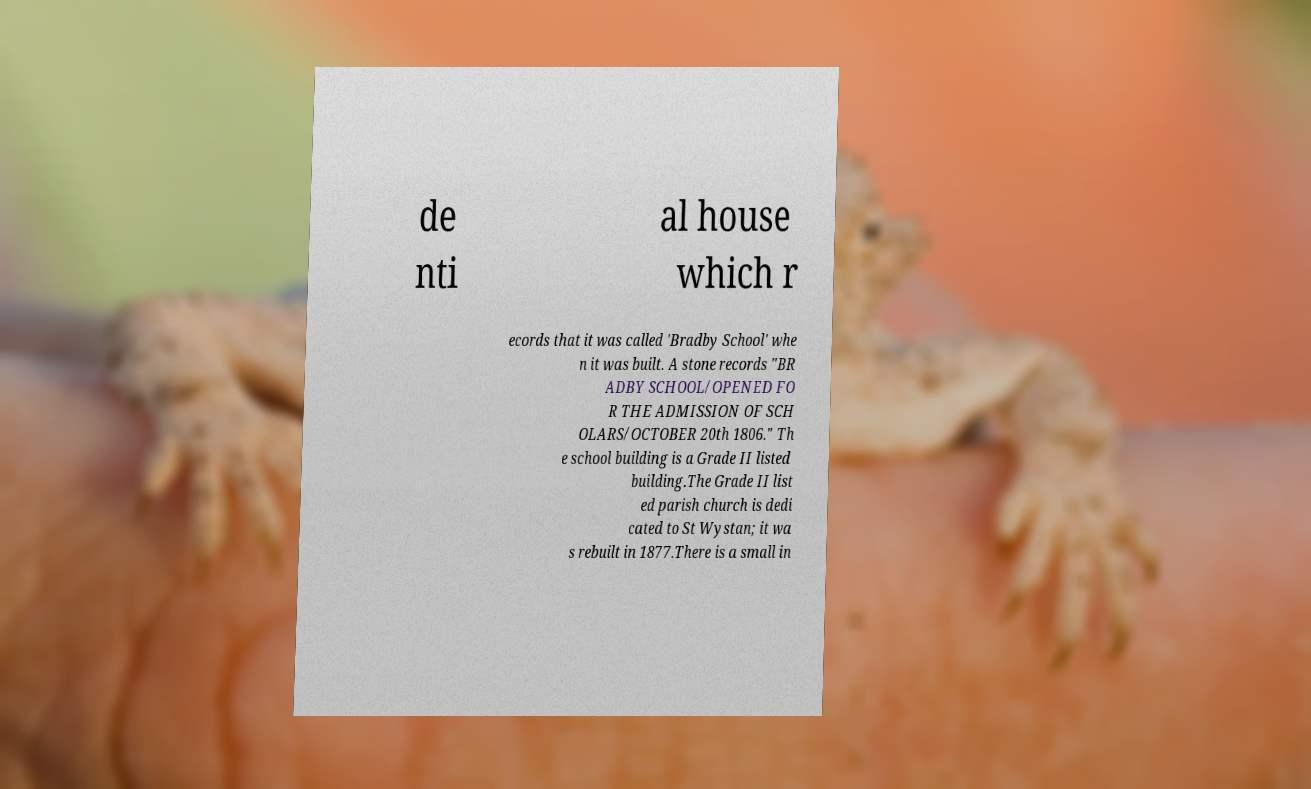Could you extract and type out the text from this image? de nti al house which r ecords that it was called 'Bradby School' whe n it was built. A stone records "BR ADBY SCHOOL/OPENED FO R THE ADMISSION OF SCH OLARS/OCTOBER 20th 1806." Th e school building is a Grade II listed building.The Grade II list ed parish church is dedi cated to St Wystan; it wa s rebuilt in 1877.There is a small in 